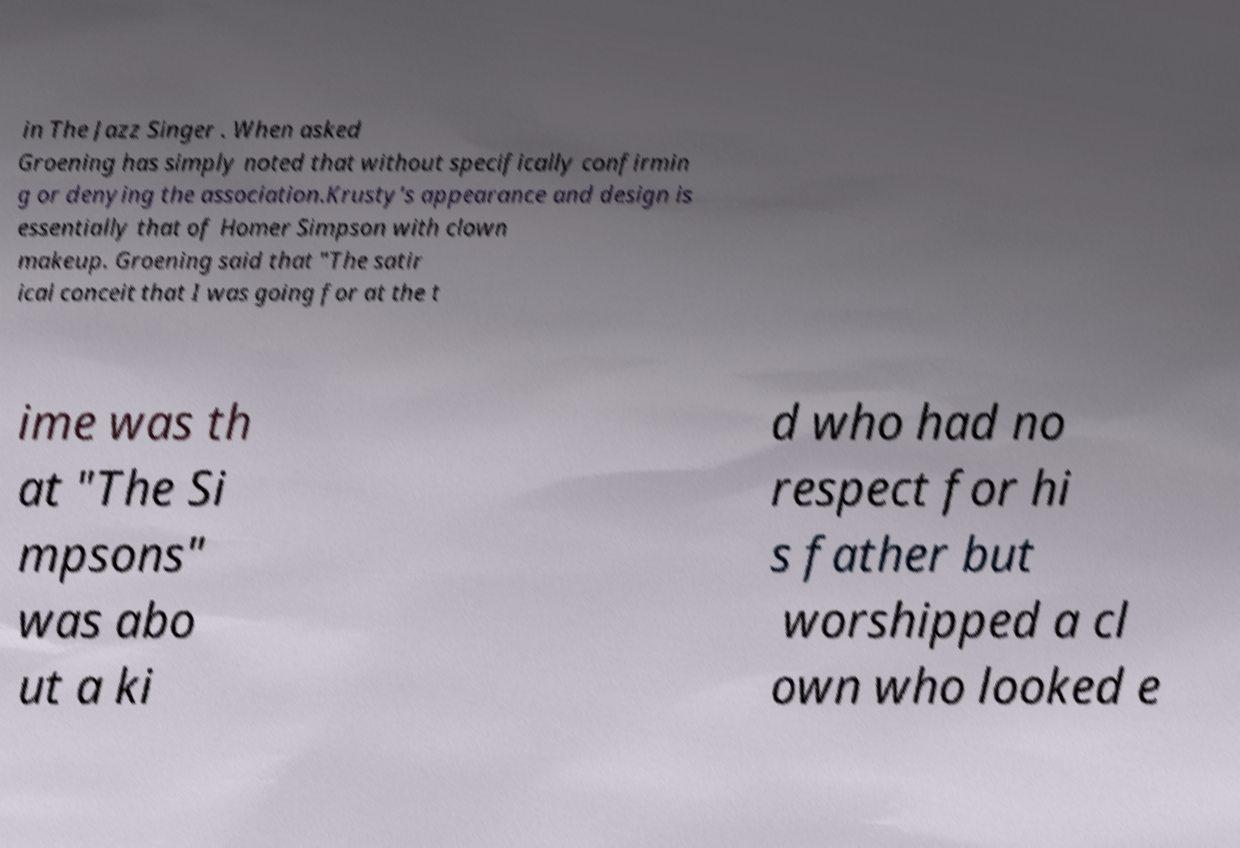Please identify and transcribe the text found in this image. in The Jazz Singer . When asked Groening has simply noted that without specifically confirmin g or denying the association.Krusty's appearance and design is essentially that of Homer Simpson with clown makeup. Groening said that "The satir ical conceit that I was going for at the t ime was th at "The Si mpsons" was abo ut a ki d who had no respect for hi s father but worshipped a cl own who looked e 